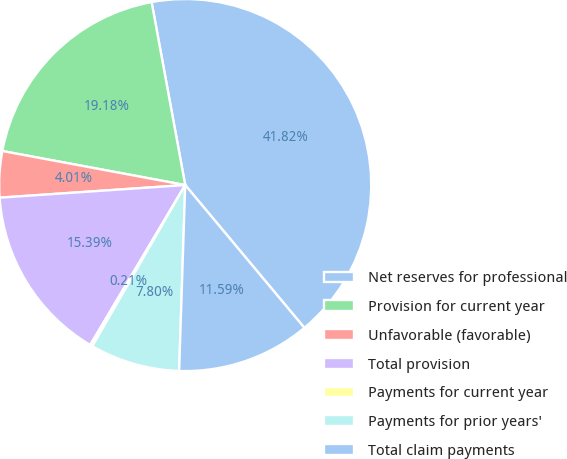Convert chart. <chart><loc_0><loc_0><loc_500><loc_500><pie_chart><fcel>Net reserves for professional<fcel>Provision for current year<fcel>Unfavorable (favorable)<fcel>Total provision<fcel>Payments for current year<fcel>Payments for prior years'<fcel>Total claim payments<nl><fcel>41.82%<fcel>19.18%<fcel>4.01%<fcel>15.39%<fcel>0.21%<fcel>7.8%<fcel>11.59%<nl></chart> 